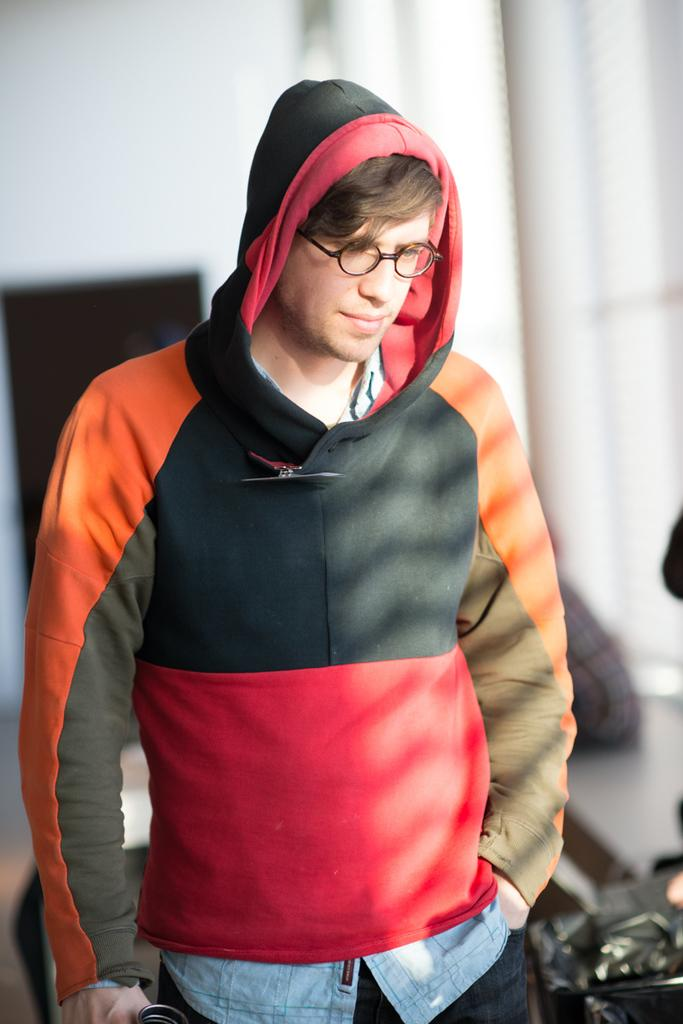Who is present in the image? There is a person in the image. What is the person wearing? The person is wearing clothes. Are there any accessories visible on the person? Yes, the person is wearing spectacles. How many sheep can be seen in the image? There are no sheep present in the image. Why is the person crying in the image? The person is not crying in the image; there is no indication of emotion or action beyond the visible attire and accessories. 